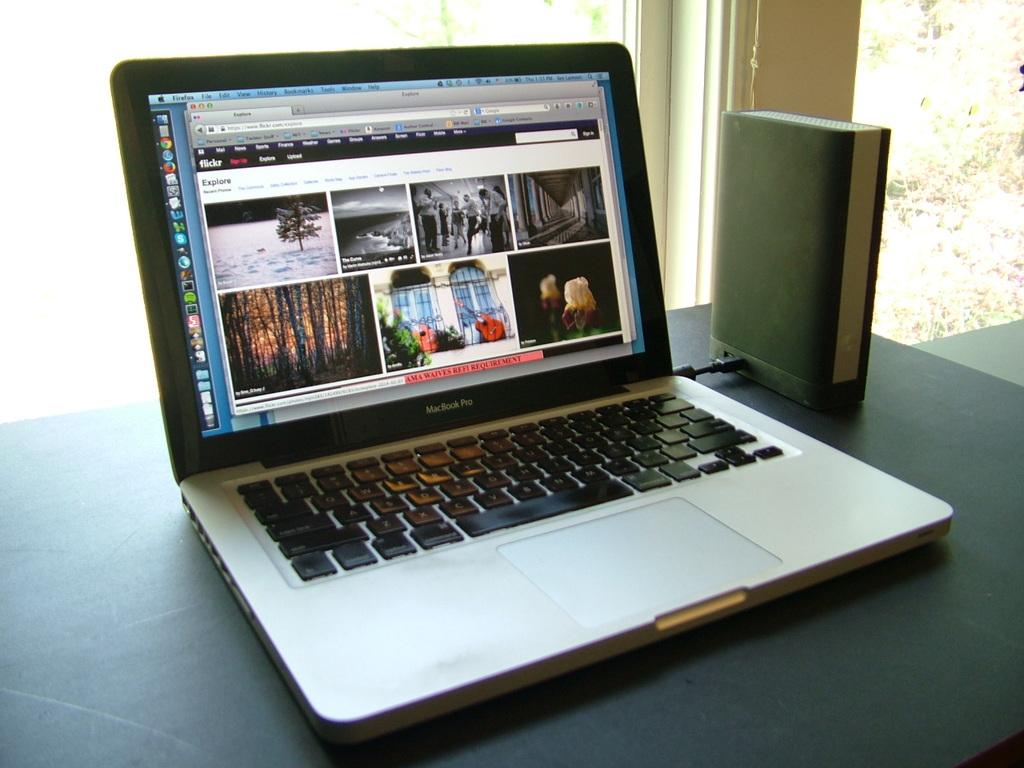What brand of laptop is this?
Your answer should be very brief. Macbook pro. 